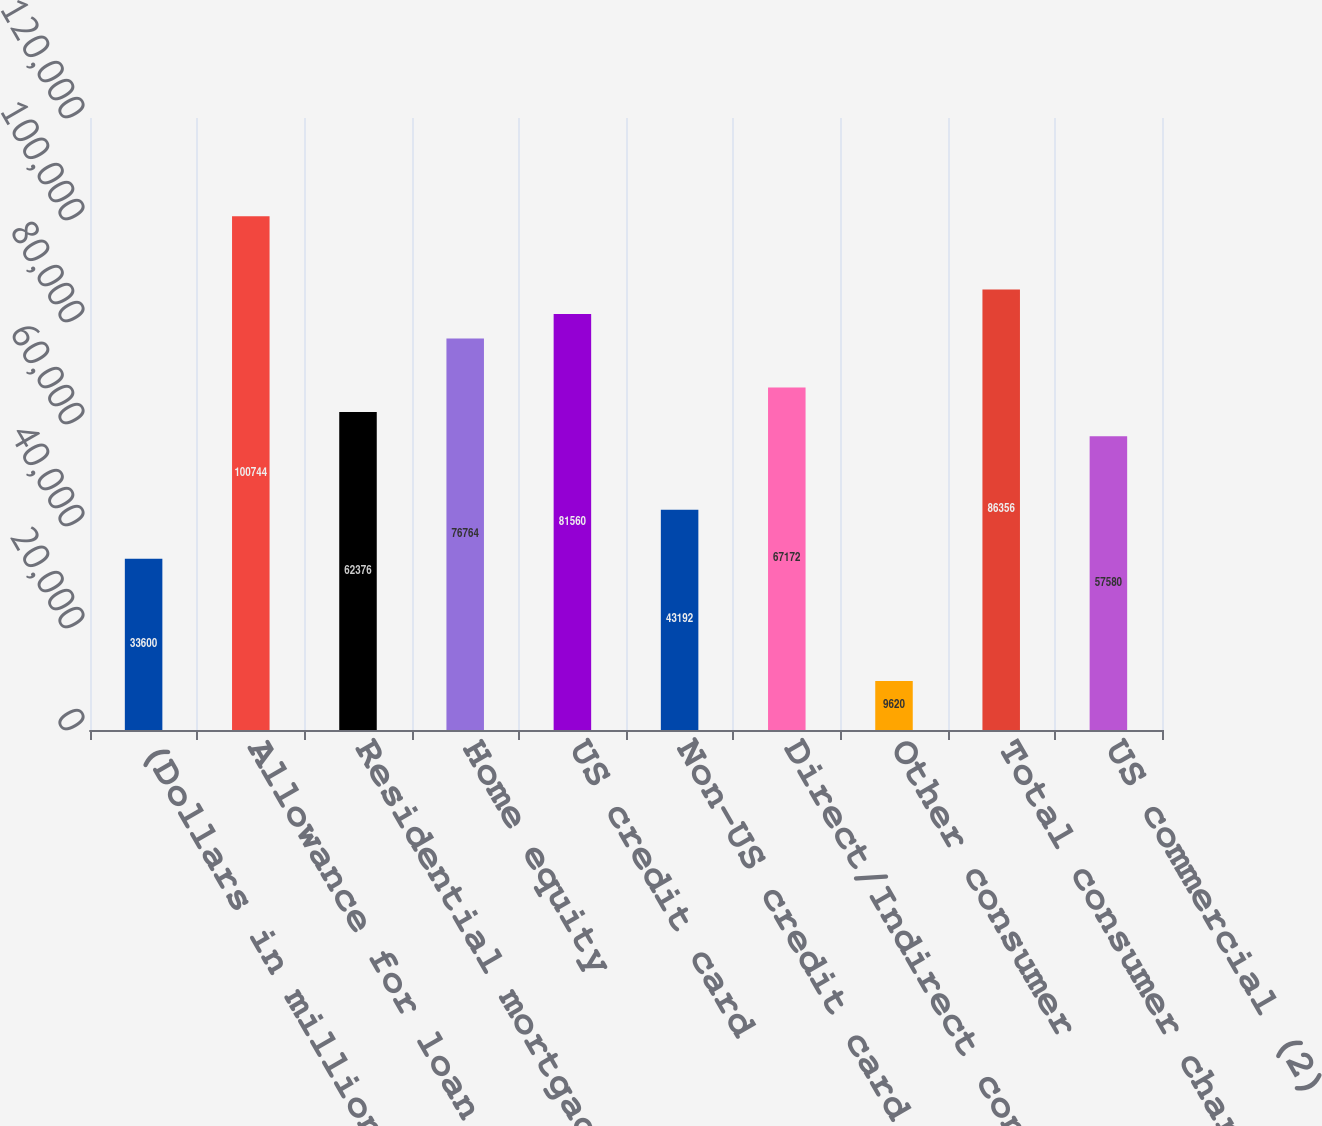<chart> <loc_0><loc_0><loc_500><loc_500><bar_chart><fcel>(Dollars in millions)<fcel>Allowance for loan and lease<fcel>Residential mortgage<fcel>Home equity<fcel>US credit card<fcel>Non-US credit card<fcel>Direct/Indirect consumer<fcel>Other consumer<fcel>Total consumer charge-offs<fcel>US commercial (2)<nl><fcel>33600<fcel>100744<fcel>62376<fcel>76764<fcel>81560<fcel>43192<fcel>67172<fcel>9620<fcel>86356<fcel>57580<nl></chart> 